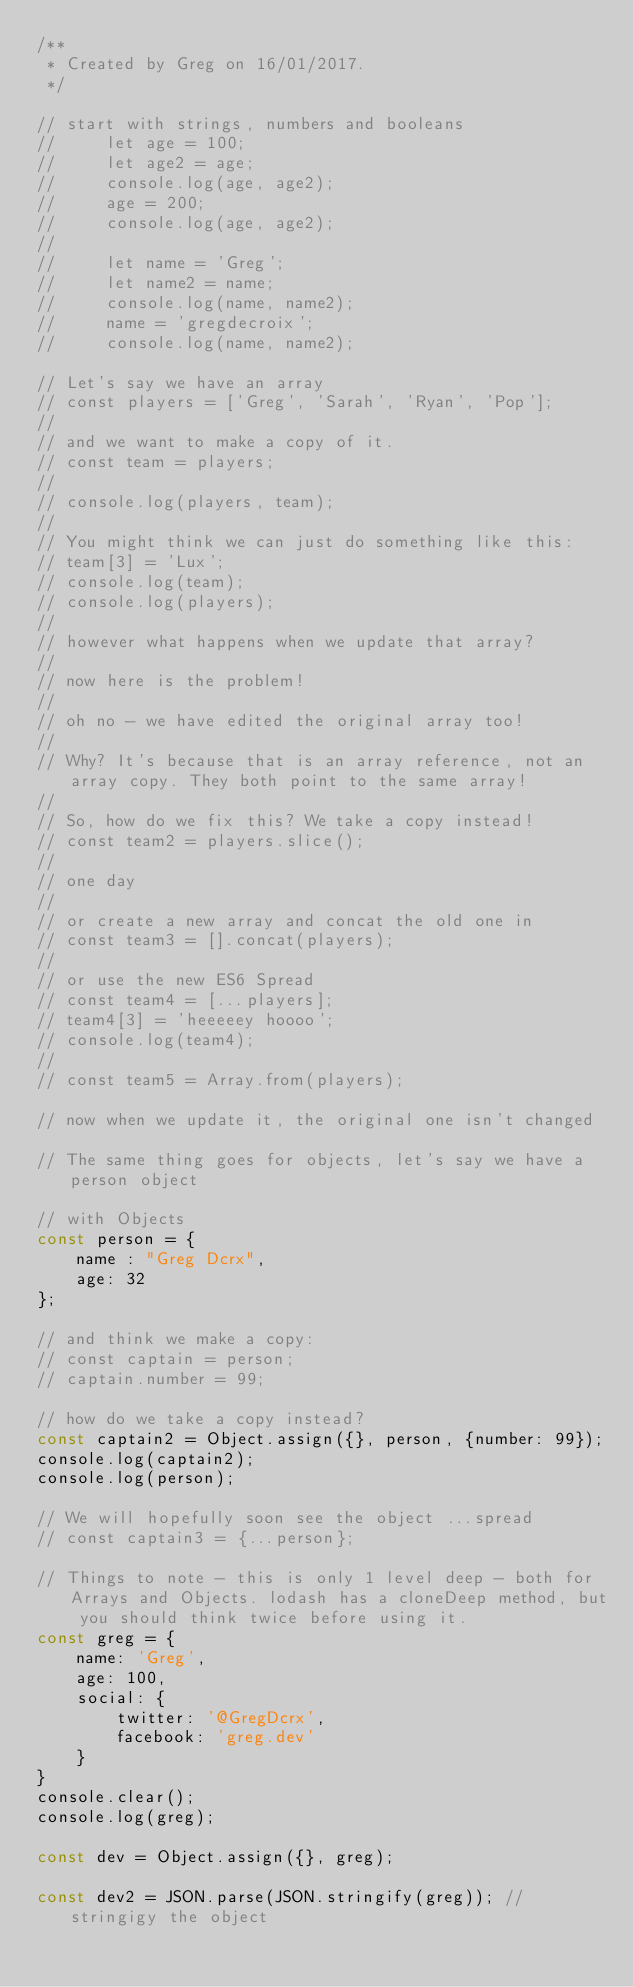Convert code to text. <code><loc_0><loc_0><loc_500><loc_500><_JavaScript_>/**
 * Created by Greg on 16/01/2017.
 */

// start with strings, numbers and booleans
//     let age = 100;
//     let age2 = age;
//     console.log(age, age2);
//     age = 200;
//     console.log(age, age2);
//
//     let name = 'Greg';
//     let name2 = name;
//     console.log(name, name2);
//     name = 'gregdecroix';
//     console.log(name, name2);

// Let's say we have an array
// const players = ['Greg', 'Sarah', 'Ryan', 'Pop'];
//
// and we want to make a copy of it.
// const team = players;
//
// console.log(players, team);
//
// You might think we can just do something like this:
// team[3] = 'Lux';
// console.log(team);
// console.log(players);
//
// however what happens when we update that array?
//
// now here is the problem!
//
// oh no - we have edited the original array too!
//
// Why? It's because that is an array reference, not an array copy. They both point to the same array!
//
// So, how do we fix this? We take a copy instead!
// const team2 = players.slice();
//
// one day
//
// or create a new array and concat the old one in
// const team3 = [].concat(players);
//
// or use the new ES6 Spread
// const team4 = [...players];
// team4[3] = 'heeeeey hoooo';
// console.log(team4);
//
// const team5 = Array.from(players);

// now when we update it, the original one isn't changed

// The same thing goes for objects, let's say we have a person object

// with Objects
const person = {
    name : "Greg Dcrx",
    age: 32
};

// and think we make a copy:
// const captain = person;
// captain.number = 99;

// how do we take a copy instead?
const captain2 = Object.assign({}, person, {number: 99});
console.log(captain2);
console.log(person);

// We will hopefully soon see the object ...spread
// const captain3 = {...person};

// Things to note - this is only 1 level deep - both for Arrays and Objects. lodash has a cloneDeep method, but you should think twice before using it.
const greg = {
    name: 'Greg',
    age: 100,
    social: {
        twitter: '@GregDcrx',
        facebook: 'greg.dev'
    }
}
console.clear();
console.log(greg);

const dev = Object.assign({}, greg);

const dev2 = JSON.parse(JSON.stringify(greg)); // stringigy the object</code> 